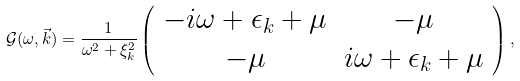<formula> <loc_0><loc_0><loc_500><loc_500>\mathcal { G } ( \omega , \vec { k } ) = \frac { 1 } { \omega ^ { 2 } + \xi _ { k } ^ { 2 } } \left ( \begin{array} { c c } - i \omega + \epsilon _ { k } + \mu & - \mu \\ - \mu & i \omega + \epsilon _ { k } + \mu \end{array} \right ) ,</formula> 